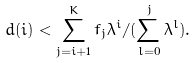Convert formula to latex. <formula><loc_0><loc_0><loc_500><loc_500>d ( i ) < \sum _ { j = i + 1 } ^ { K } f _ { j } \lambda ^ { i } / ( \sum _ { l = 0 } ^ { j } \lambda ^ { l } ) .</formula> 